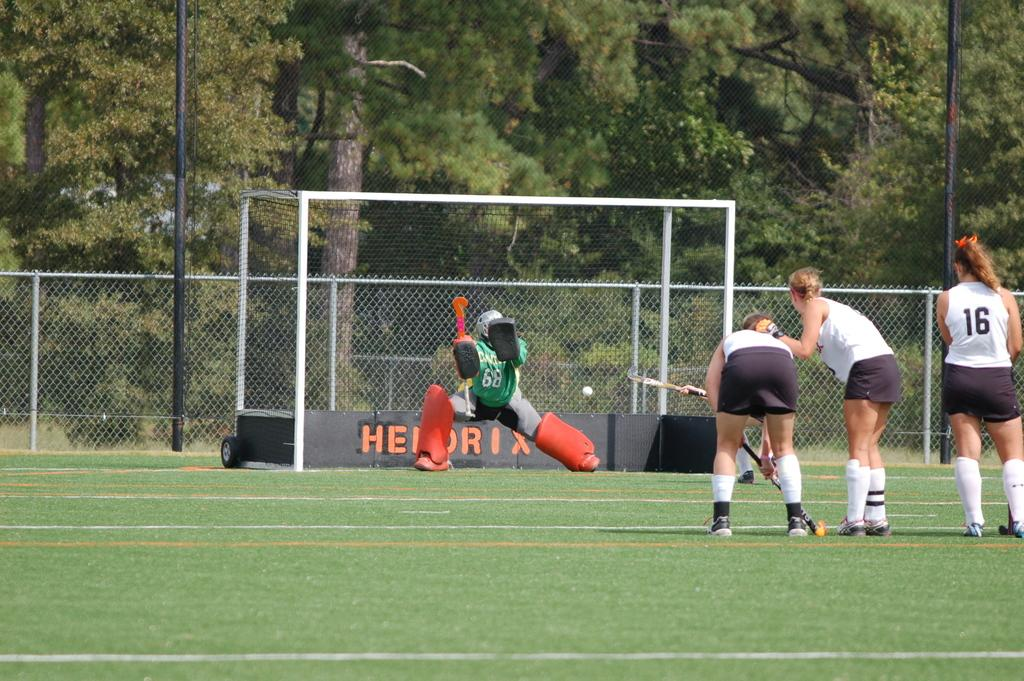Provide a one-sentence caption for the provided image. field hockey players on a field with the words hendrix in the goal. 